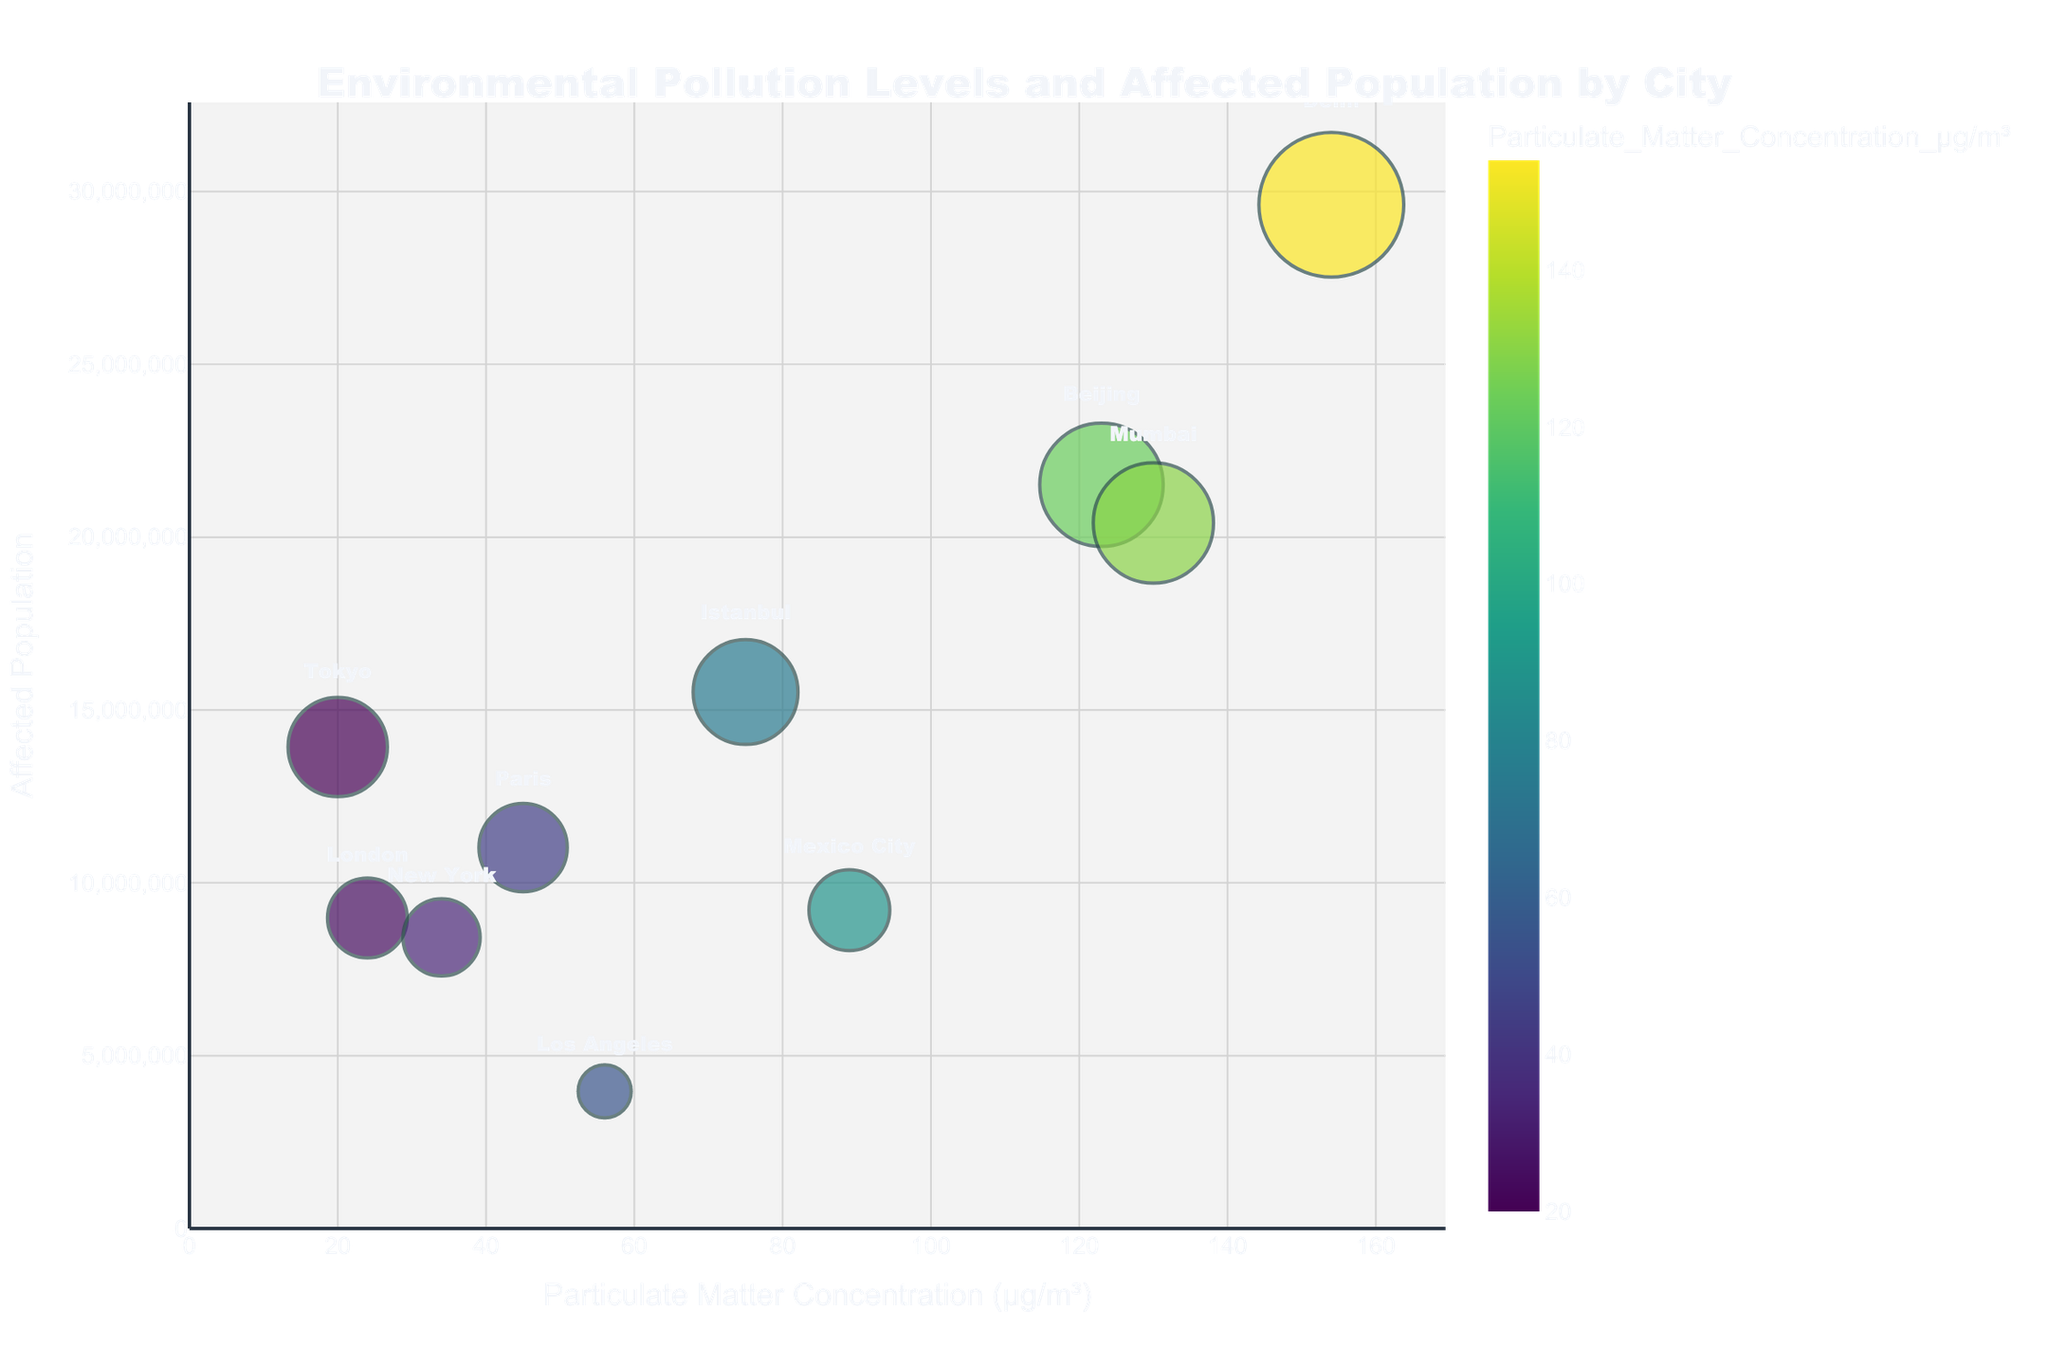What's the title of the chart? The title of the chart is typically located at the top of the figure. In this case, the chart title is displayed in large, bold text.
Answer: Environmental Pollution Levels and Affected Population by City What is the approximate particulate matter concentration for New York? Locate the bubble labeled "New York" on the x-axis, which represents the particulate matter concentration. New York's bubble is around the middle-left region on the x-axis.
Answer: 34 µg/m³ Which city has the highest affected population? To find the city with the highest affected population, locate the largest bubble on the plot, since the size of the bubbles is proportional to the affected population. The largest bubble corresponds to Delhi.
Answer: Delhi What is the particulate matter concentration range displayed on the x-axis? The x-axis starts from 0 and ends slightly above the highest data point. Since the maximum concentration is around 154 µg/m³, the x-axis range is approximately from 0 to about 170.
Answer: 0 to 170 µg/m³ Which city has the smallest bubble and what does it indicate? The smallest bubble represents the city with the lowest affected population. By observing the bubble sizes, the smallest one appears to be next to "Los Angeles" which indicates it has the lowest affected population.
Answer: Los Angeles How does the particulate matter concentration of Istanbul compare to that of London? Locate the bubbles for Istanbul and London on the x-axis. Istanbul's bubble is further to the right compared to London's, indicating Istanbul has a higher particulate matter concentration than London.
Answer: Istanbul has a higher concentration than London What is the total affected population of Delhi and Mumbai combined? Find the affected populations for Delhi and Mumbai from their corresponding bubbles. Delhi's affected population is approximately 29,617,000, and Mumbai's is approximately 20,411,000. Summing them up: 29,617,000 + 20,411,000 = 50,028,000.
Answer: 50,028,000 What is the color gradient used in this chart? The color of the bubbles correlates with particulate matter concentration and follows a specific gradient. Observing the color range goes from a dark to light gradient, identified as the Viridis color scale.
Answer: Viridis Which city has the second highest particulate matter concentration? Locate the bubbles based on their position on the x-axis. The bubble to the immediate left of the highest one (Delhi) represents the second-highest concentration. This bubble belongs to Beijing.
Answer: Beijing 